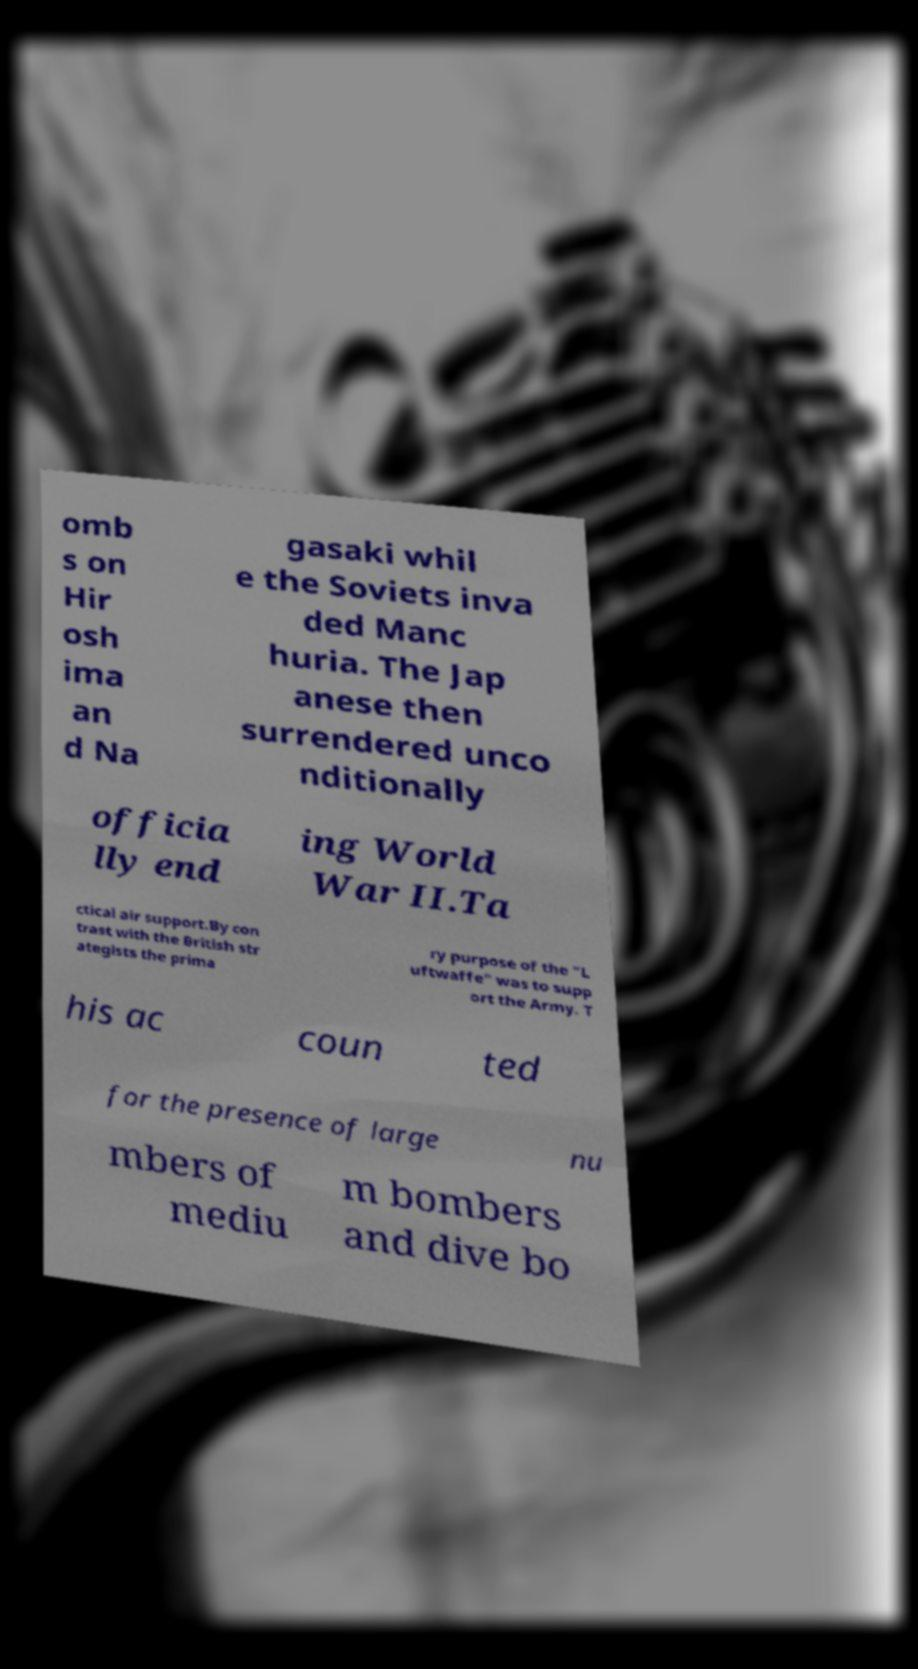Could you extract and type out the text from this image? omb s on Hir osh ima an d Na gasaki whil e the Soviets inva ded Manc huria. The Jap anese then surrendered unco nditionally officia lly end ing World War II.Ta ctical air support.By con trast with the British str ategists the prima ry purpose of the "L uftwaffe" was to supp ort the Army. T his ac coun ted for the presence of large nu mbers of mediu m bombers and dive bo 